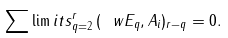<formula> <loc_0><loc_0><loc_500><loc_500>\sum \lim i t s _ { q = 2 } ^ { r } \, ( \ w E _ { q } , A _ { i } ) _ { r - q } = 0 .</formula> 